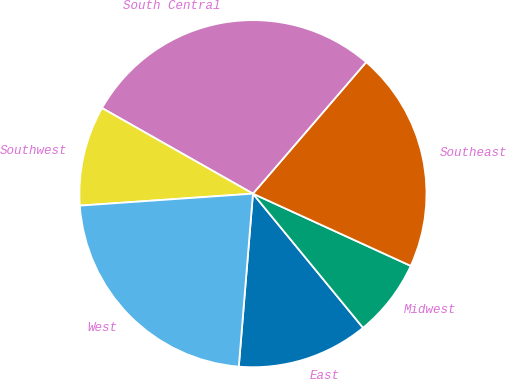Convert chart to OTSL. <chart><loc_0><loc_0><loc_500><loc_500><pie_chart><fcel>East<fcel>Midwest<fcel>Southeast<fcel>South Central<fcel>Southwest<fcel>West<nl><fcel>12.24%<fcel>7.23%<fcel>20.52%<fcel>28.1%<fcel>9.31%<fcel>22.6%<nl></chart> 